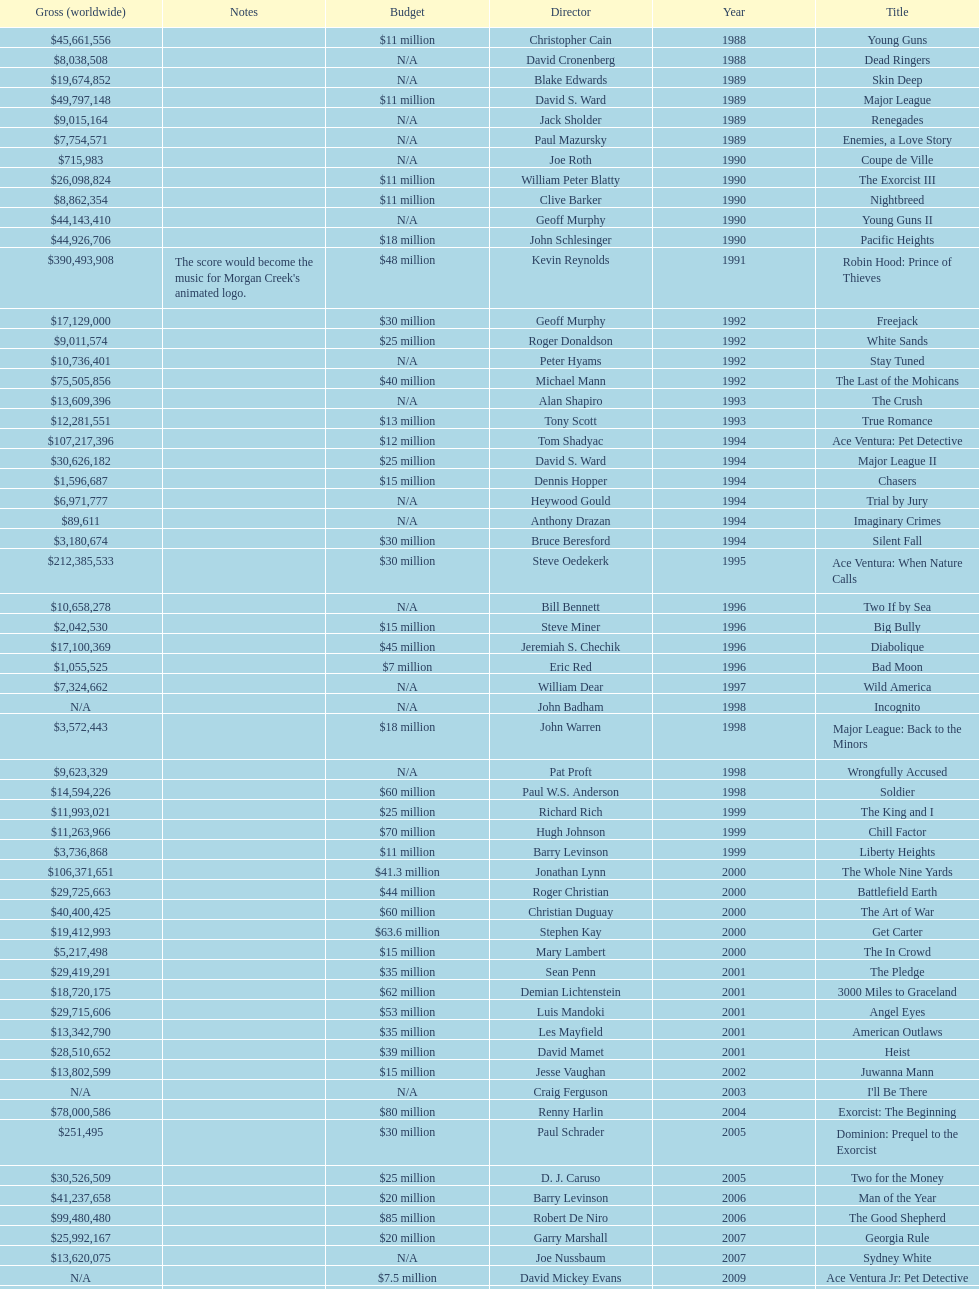What is the number of films directed by david s. ward? 2. 